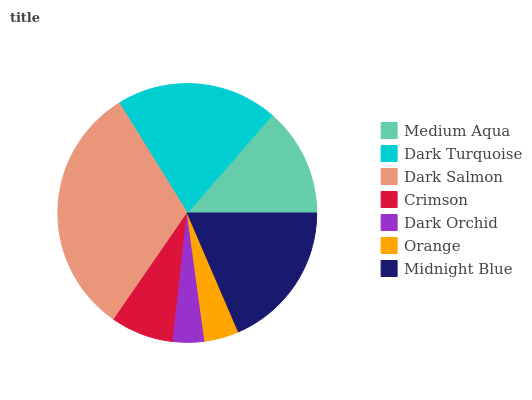Is Dark Orchid the minimum?
Answer yes or no. Yes. Is Dark Salmon the maximum?
Answer yes or no. Yes. Is Dark Turquoise the minimum?
Answer yes or no. No. Is Dark Turquoise the maximum?
Answer yes or no. No. Is Dark Turquoise greater than Medium Aqua?
Answer yes or no. Yes. Is Medium Aqua less than Dark Turquoise?
Answer yes or no. Yes. Is Medium Aqua greater than Dark Turquoise?
Answer yes or no. No. Is Dark Turquoise less than Medium Aqua?
Answer yes or no. No. Is Medium Aqua the high median?
Answer yes or no. Yes. Is Medium Aqua the low median?
Answer yes or no. Yes. Is Dark Salmon the high median?
Answer yes or no. No. Is Dark Orchid the low median?
Answer yes or no. No. 